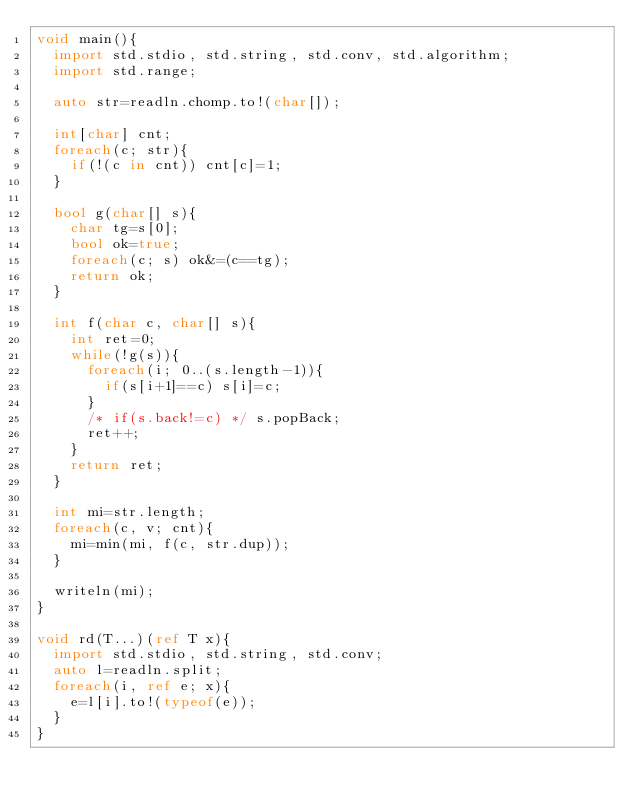<code> <loc_0><loc_0><loc_500><loc_500><_D_>void main(){
  import std.stdio, std.string, std.conv, std.algorithm;
  import std.range;

  auto str=readln.chomp.to!(char[]);

  int[char] cnt;
  foreach(c; str){
    if(!(c in cnt)) cnt[c]=1;
  }

  bool g(char[] s){
    char tg=s[0];
    bool ok=true;
    foreach(c; s) ok&=(c==tg);
    return ok;
  }

  int f(char c, char[] s){
    int ret=0;
    while(!g(s)){
      foreach(i; 0..(s.length-1)){
        if(s[i+1]==c) s[i]=c;
      }
      /* if(s.back!=c) */ s.popBack;
      ret++;
    }
    return ret;
  }

  int mi=str.length;
  foreach(c, v; cnt){
    mi=min(mi, f(c, str.dup));
  }

  writeln(mi);
}

void rd(T...)(ref T x){
  import std.stdio, std.string, std.conv;
  auto l=readln.split;
  foreach(i, ref e; x){
    e=l[i].to!(typeof(e));
  }
}</code> 